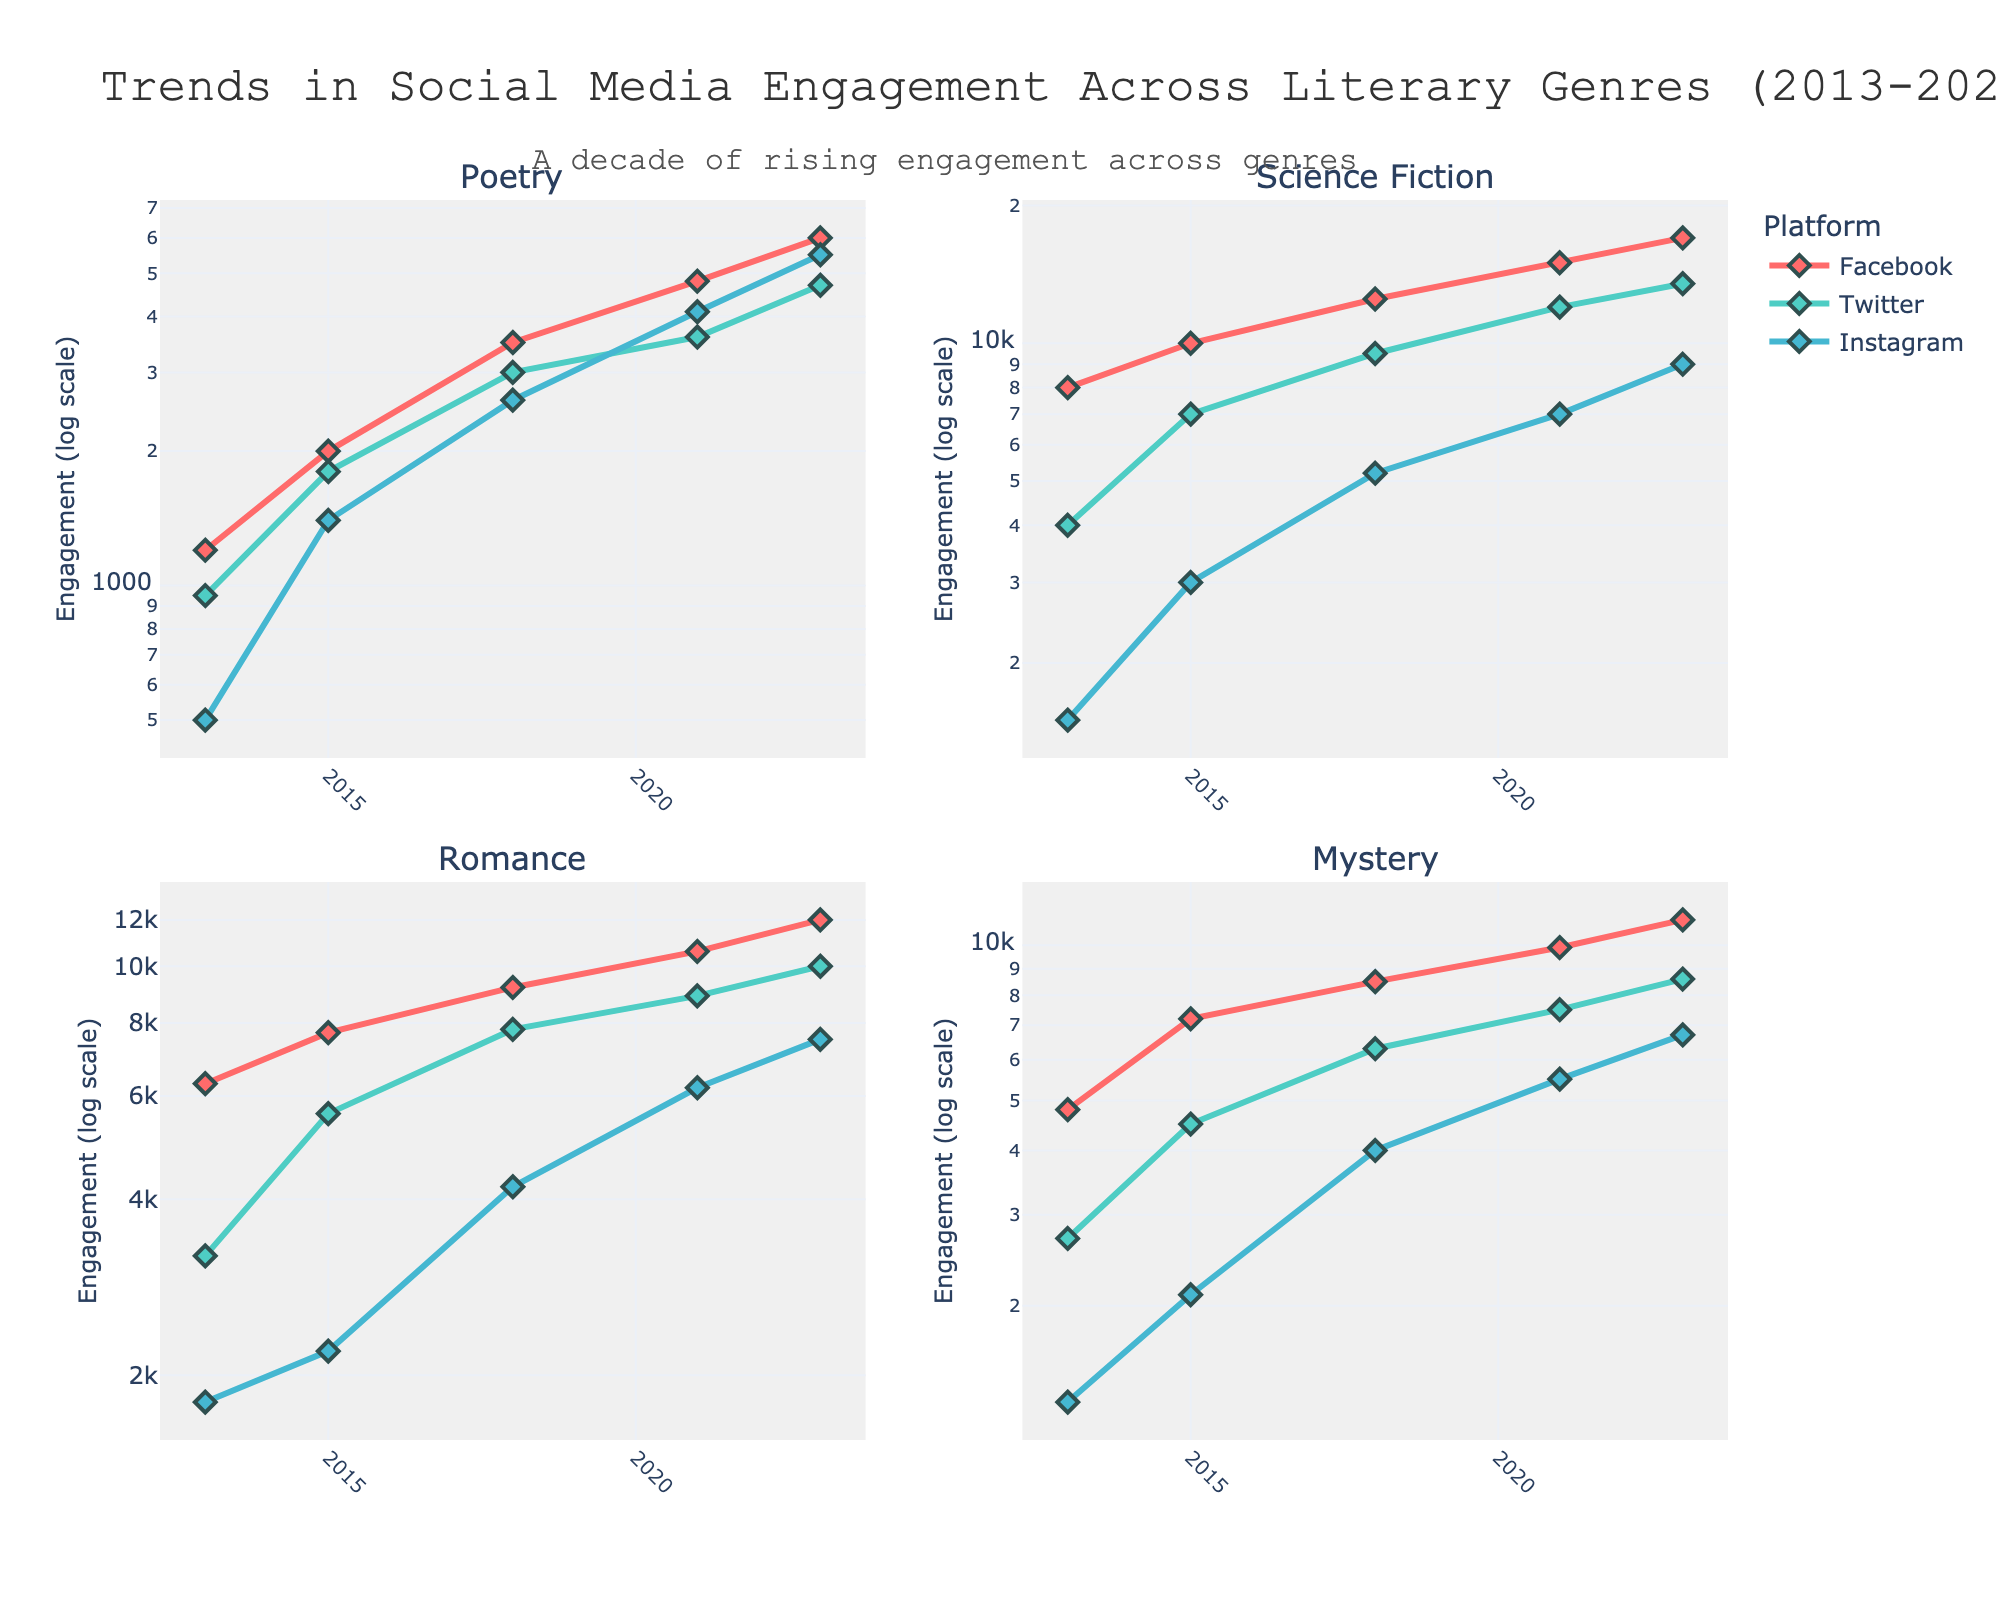What is the title of the figure? The title of the figure is prominently displayed at the top and can be read directly.
Answer: Trends in Social Media Engagement Across Literary Genres (2013-2023) Which platform has the highest engagement for Science Fiction in 2023? The figure shows the engagement trends, and Science Fiction has lines for Facebook, Twitter, and Instagram in 2023.
Answer: Facebook How does Poetry engagement on Instagram in 2021 compare to 2013? By looking at the trend lines for Poetry on Instagram in both years, we can compare the engagement values. In 2013, it's 500, and in 2021, it's around 4100.
Answer: It increased Which genre experienced the highest overall engagement on Instagram in 2018? By comparing the peaks of the lines representing Instagram engagement for all genres in 2018, Science Fiction stands out with an engagement value of around 5200.
Answer: Science Fiction What trend do you observe in Romance engagement on Twitter from 2013 to 2023? Observing the Twitter line for Romance, we see a steady increase from 3200 in 2013 to 10000 in 2023.
Answer: Increasing What is the largest increase in Facebook engagement for any genre between 2013 and 2023? Observing the data points for each genre on Facebook, Science Fiction shows the largest increase from 8000 in 2013 to 17000 in 2023.
Answer: 9000 Which genre had the least Instagram engagement in 2015? By comparing the Instagram lines for all genres in 2015, Poetry had the least engagement, around 1400.
Answer: Poetry Which platforms show log-scaled y-axes in the subplots? By looking at the y-axes in the subplots, all platforms (Facebook, Twitter, Instagram) show log-scaled y-axes across all genres.
Answer: All platforms How many genres are shown in the figure? The subplot titles list the genres, which can be counted directly.
Answer: 4 Based on the trends, which platform is increasingly popular for Poetry from 2013 to 2023? Observing the trend lines for Poetry on all platforms, Instagram shows steady and significant growth, suggesting increasing popularity.
Answer: Instagram 